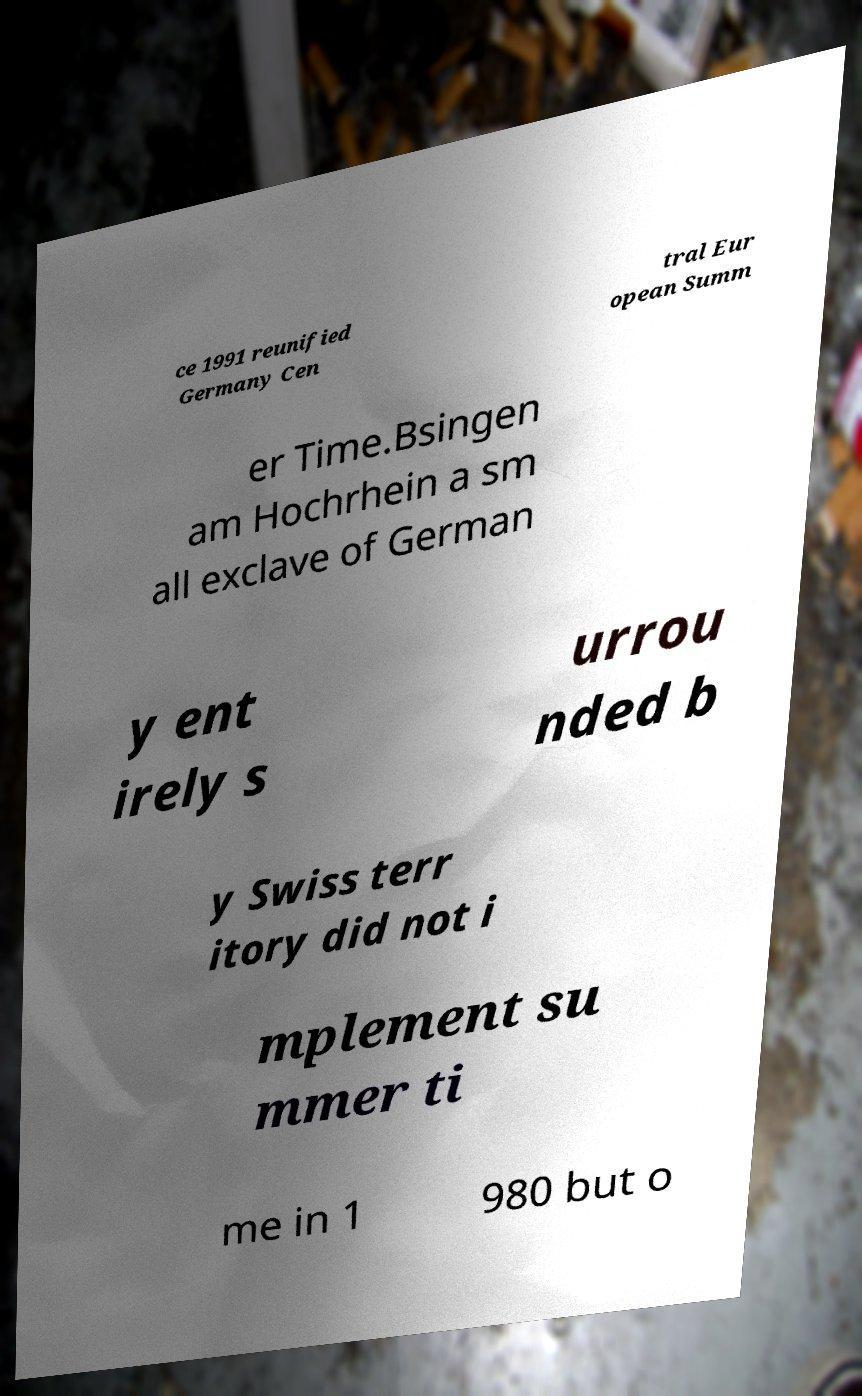What messages or text are displayed in this image? I need them in a readable, typed format. ce 1991 reunified Germany Cen tral Eur opean Summ er Time.Bsingen am Hochrhein a sm all exclave of German y ent irely s urrou nded b y Swiss terr itory did not i mplement su mmer ti me in 1 980 but o 